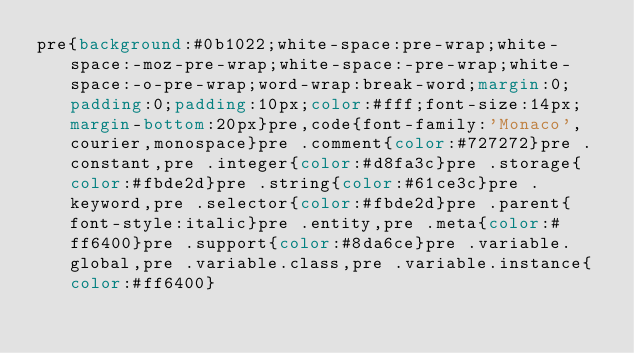Convert code to text. <code><loc_0><loc_0><loc_500><loc_500><_CSS_>pre{background:#0b1022;white-space:pre-wrap;white-space:-moz-pre-wrap;white-space:-pre-wrap;white-space:-o-pre-wrap;word-wrap:break-word;margin:0;padding:0;padding:10px;color:#fff;font-size:14px;margin-bottom:20px}pre,code{font-family:'Monaco',courier,monospace}pre .comment{color:#727272}pre .constant,pre .integer{color:#d8fa3c}pre .storage{color:#fbde2d}pre .string{color:#61ce3c}pre .keyword,pre .selector{color:#fbde2d}pre .parent{font-style:italic}pre .entity,pre .meta{color:#ff6400}pre .support{color:#8da6ce}pre .variable.global,pre .variable.class,pre .variable.instance{color:#ff6400}</code> 